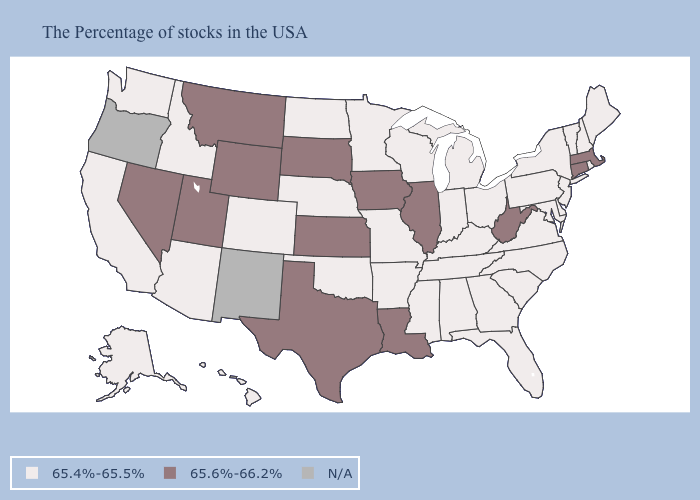What is the value of Massachusetts?
Answer briefly. 65.6%-66.2%. Among the states that border Mississippi , does Tennessee have the lowest value?
Keep it brief. Yes. What is the value of New Mexico?
Write a very short answer. N/A. Name the states that have a value in the range 65.4%-65.5%?
Concise answer only. Maine, Rhode Island, New Hampshire, Vermont, New York, New Jersey, Delaware, Maryland, Pennsylvania, Virginia, North Carolina, South Carolina, Ohio, Florida, Georgia, Michigan, Kentucky, Indiana, Alabama, Tennessee, Wisconsin, Mississippi, Missouri, Arkansas, Minnesota, Nebraska, Oklahoma, North Dakota, Colorado, Arizona, Idaho, California, Washington, Alaska, Hawaii. Among the states that border North Dakota , does Montana have the highest value?
Keep it brief. Yes. Name the states that have a value in the range N/A?
Concise answer only. New Mexico, Oregon. What is the lowest value in the MidWest?
Concise answer only. 65.4%-65.5%. What is the highest value in states that border Utah?
Answer briefly. 65.6%-66.2%. Does North Carolina have the highest value in the USA?
Short answer required. No. What is the highest value in the MidWest ?
Concise answer only. 65.6%-66.2%. Among the states that border Delaware , which have the lowest value?
Concise answer only. New Jersey, Maryland, Pennsylvania. Name the states that have a value in the range N/A?
Write a very short answer. New Mexico, Oregon. Name the states that have a value in the range 65.4%-65.5%?
Answer briefly. Maine, Rhode Island, New Hampshire, Vermont, New York, New Jersey, Delaware, Maryland, Pennsylvania, Virginia, North Carolina, South Carolina, Ohio, Florida, Georgia, Michigan, Kentucky, Indiana, Alabama, Tennessee, Wisconsin, Mississippi, Missouri, Arkansas, Minnesota, Nebraska, Oklahoma, North Dakota, Colorado, Arizona, Idaho, California, Washington, Alaska, Hawaii. What is the lowest value in the South?
Concise answer only. 65.4%-65.5%. 